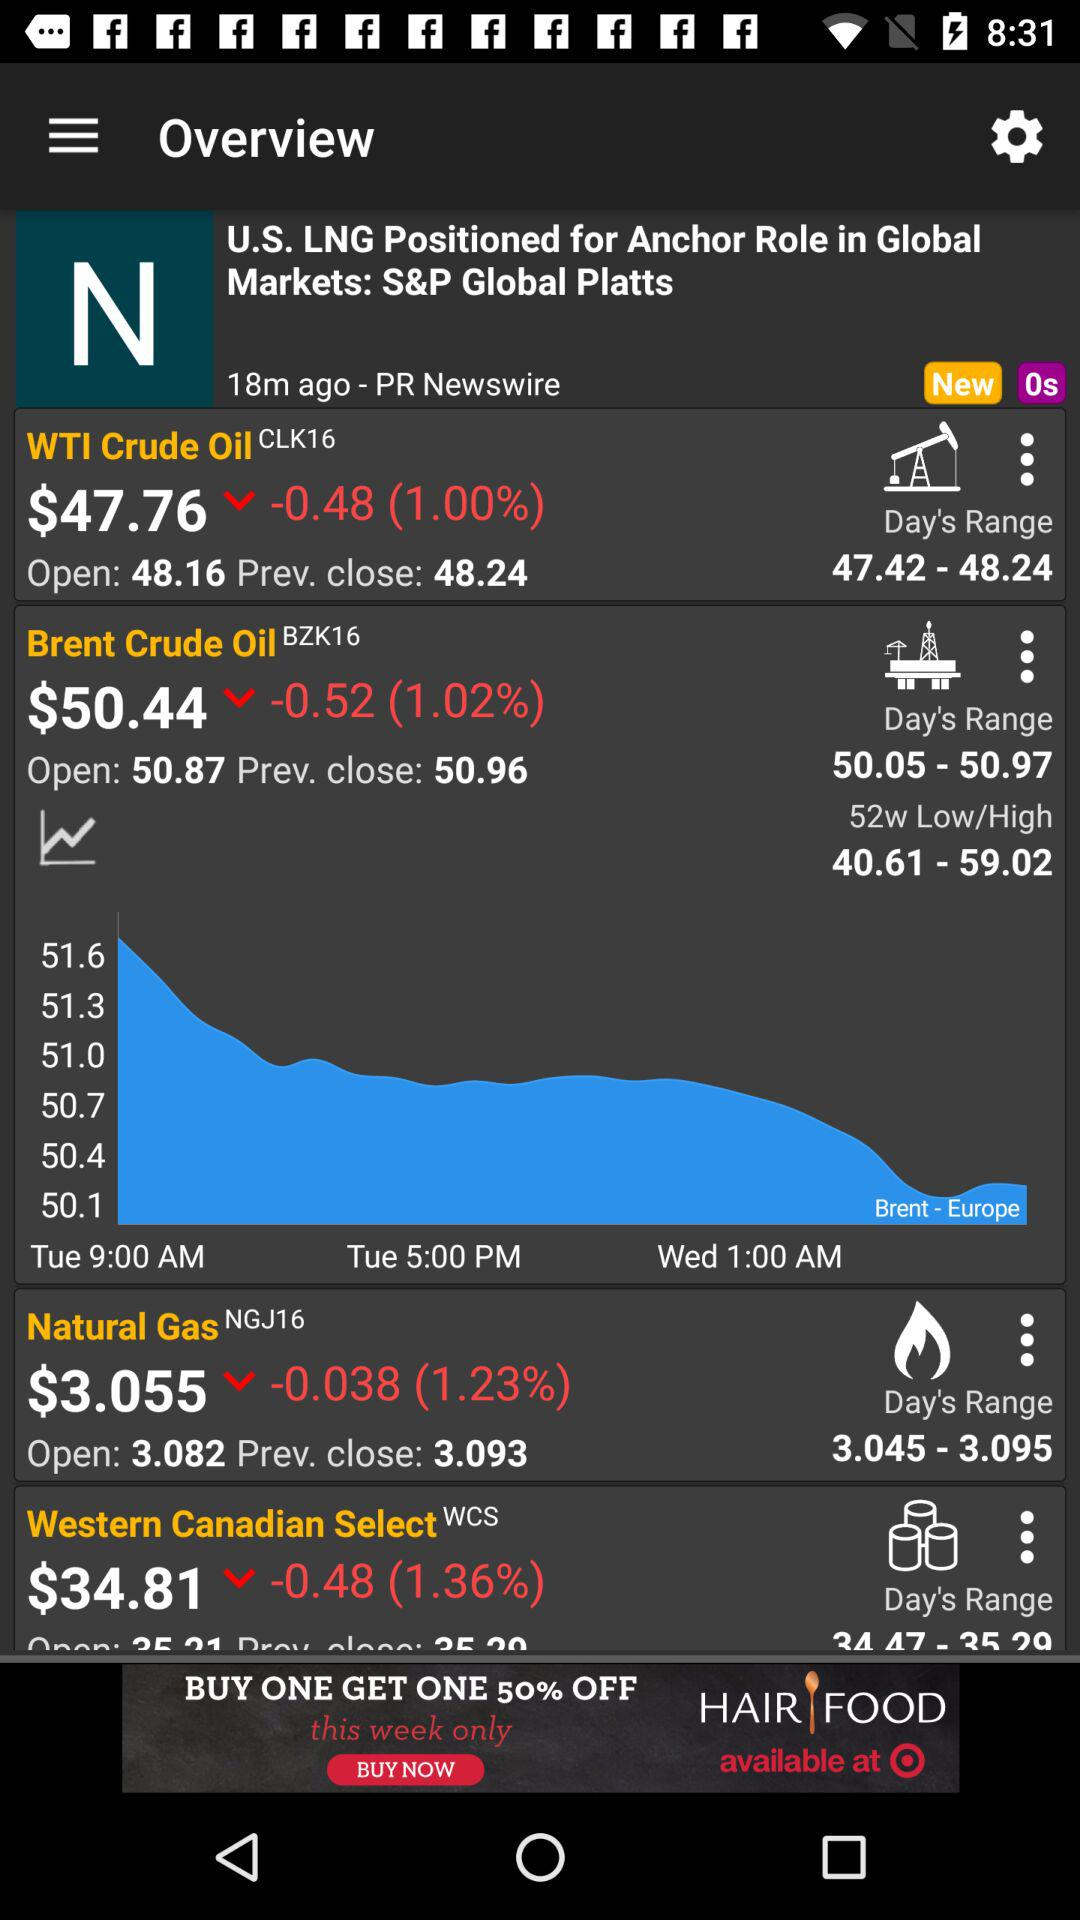What is the "Day's Range" of "Natural Gas"? The "Day's Range" of "Natural Gas" is from 3.045 to 3.095. 